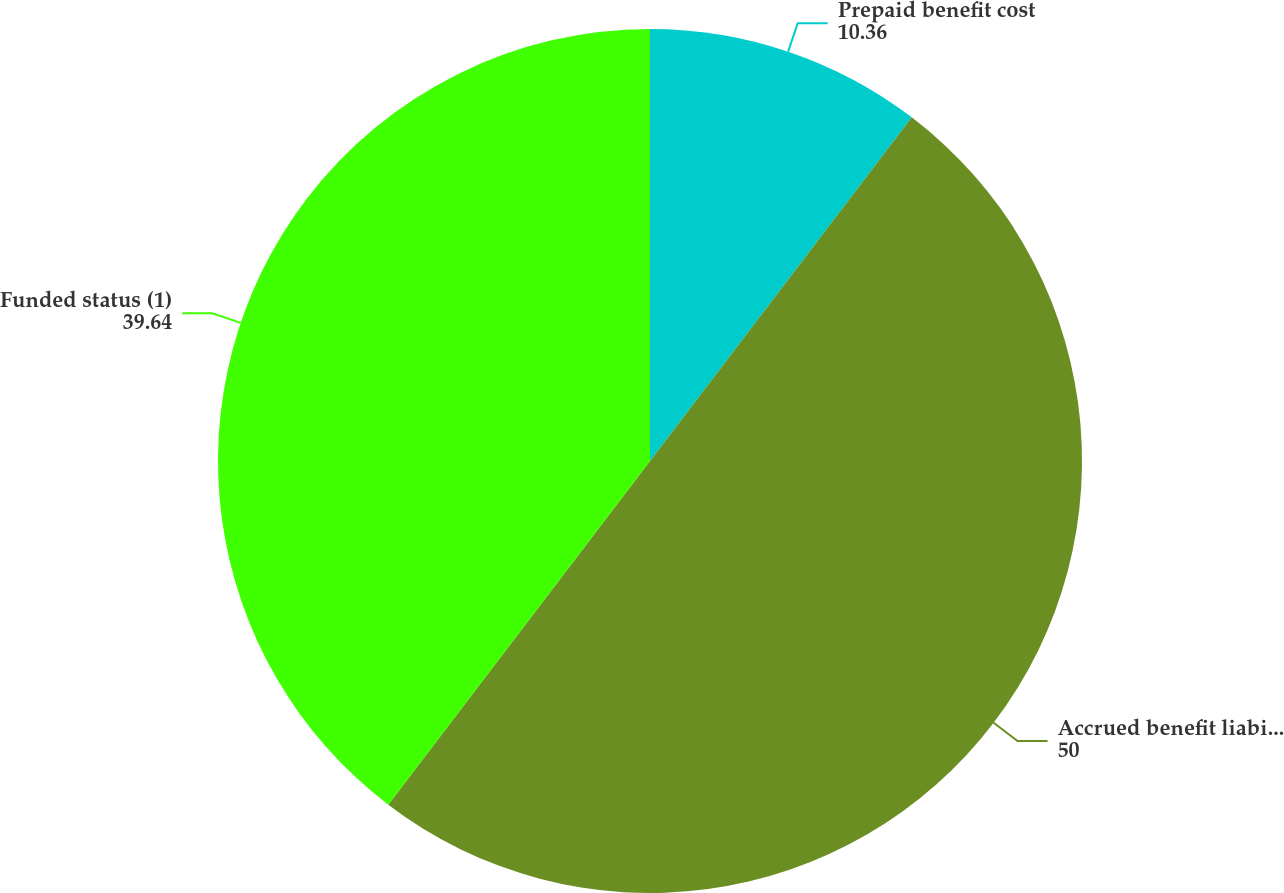Convert chart to OTSL. <chart><loc_0><loc_0><loc_500><loc_500><pie_chart><fcel>Prepaid benefit cost<fcel>Accrued benefit liability<fcel>Funded status (1)<nl><fcel>10.36%<fcel>50.0%<fcel>39.64%<nl></chart> 